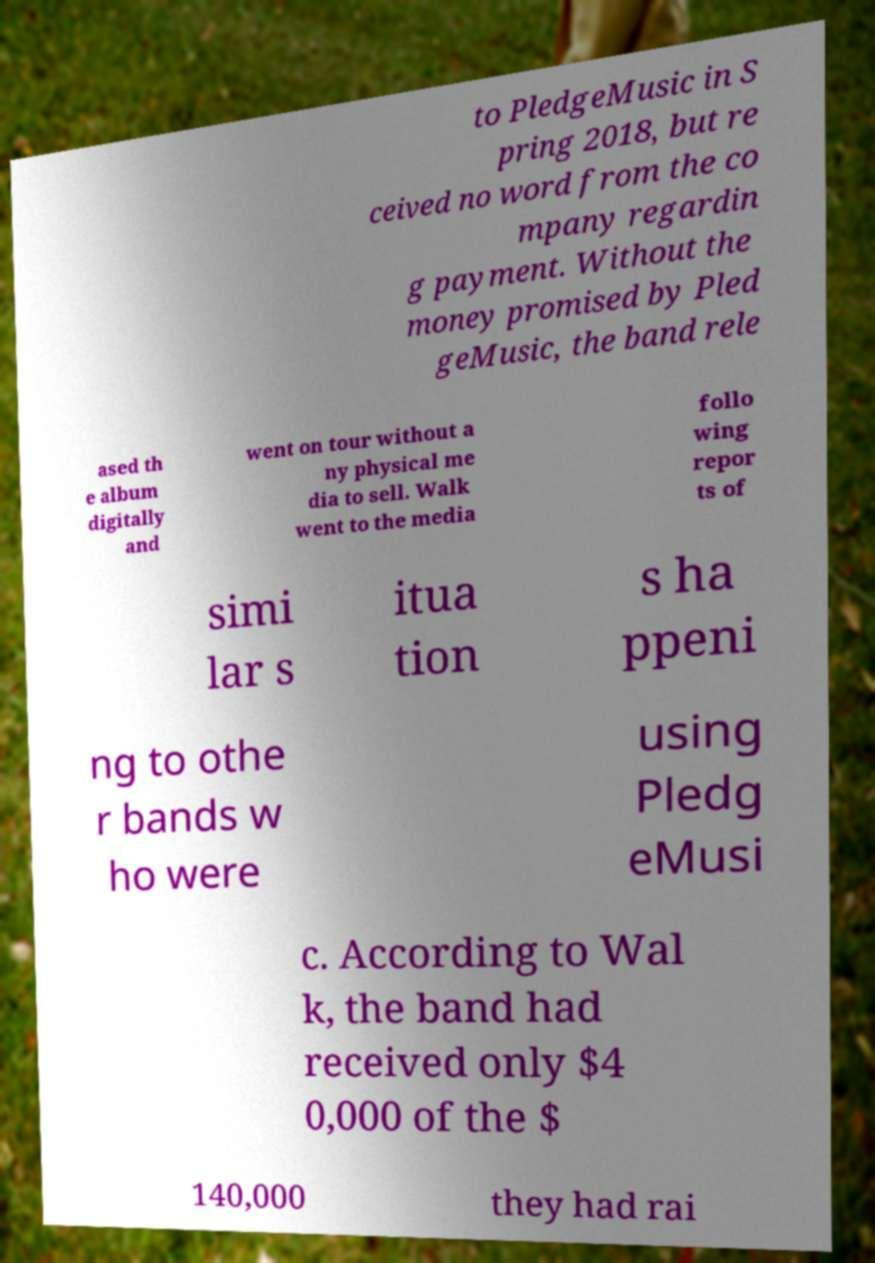Please read and relay the text visible in this image. What does it say? to PledgeMusic in S pring 2018, but re ceived no word from the co mpany regardin g payment. Without the money promised by Pled geMusic, the band rele ased th e album digitally and went on tour without a ny physical me dia to sell. Walk went to the media follo wing repor ts of simi lar s itua tion s ha ppeni ng to othe r bands w ho were using Pledg eMusi c. According to Wal k, the band had received only $4 0,000 of the $ 140,000 they had rai 